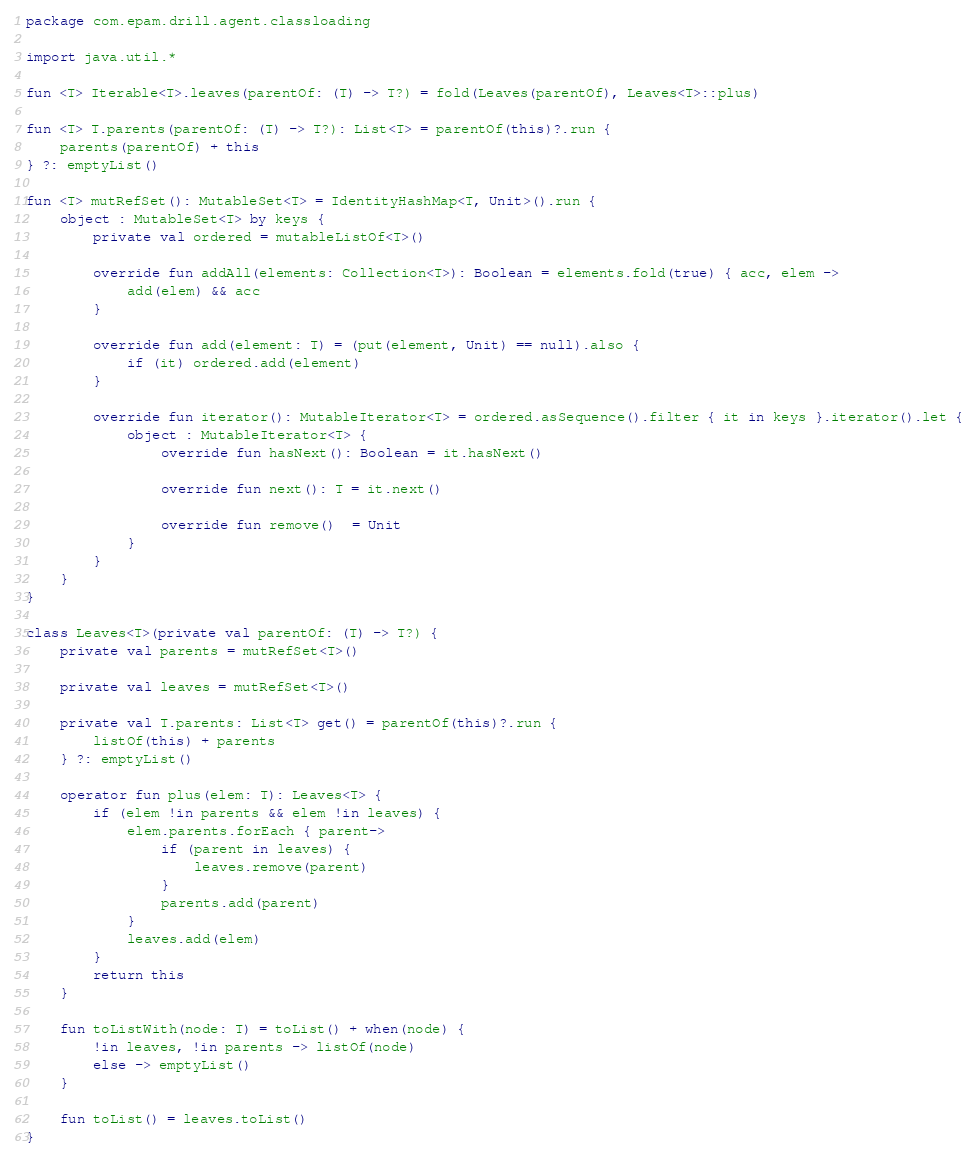<code> <loc_0><loc_0><loc_500><loc_500><_Kotlin_>package com.epam.drill.agent.classloading

import java.util.*

fun <T> Iterable<T>.leaves(parentOf: (T) -> T?) = fold(Leaves(parentOf), Leaves<T>::plus)

fun <T> T.parents(parentOf: (T) -> T?): List<T> = parentOf(this)?.run {
    parents(parentOf) + this
} ?: emptyList()

fun <T> mutRefSet(): MutableSet<T> = IdentityHashMap<T, Unit>().run {
    object : MutableSet<T> by keys {
        private val ordered = mutableListOf<T>()

        override fun addAll(elements: Collection<T>): Boolean = elements.fold(true) { acc, elem ->
            add(elem) && acc
        }

        override fun add(element: T) = (put(element, Unit) == null).also {
            if (it) ordered.add(element)
        }

        override fun iterator(): MutableIterator<T> = ordered.asSequence().filter { it in keys }.iterator().let {
            object : MutableIterator<T> {
                override fun hasNext(): Boolean = it.hasNext()

                override fun next(): T = it.next()

                override fun remove()  = Unit
            }
        }
    }
}

class Leaves<T>(private val parentOf: (T) -> T?) {
    private val parents = mutRefSet<T>()

    private val leaves = mutRefSet<T>()

    private val T.parents: List<T> get() = parentOf(this)?.run {
        listOf(this) + parents
    } ?: emptyList()

    operator fun plus(elem: T): Leaves<T> {
        if (elem !in parents && elem !in leaves) {
            elem.parents.forEach { parent->
                if (parent in leaves) {
                    leaves.remove(parent)
                }
                parents.add(parent)
            }
            leaves.add(elem)
        }
        return this
    }

    fun toListWith(node: T) = toList() + when(node) {
        !in leaves, !in parents -> listOf(node)
        else -> emptyList()
    }

    fun toList() = leaves.toList()
}
</code> 